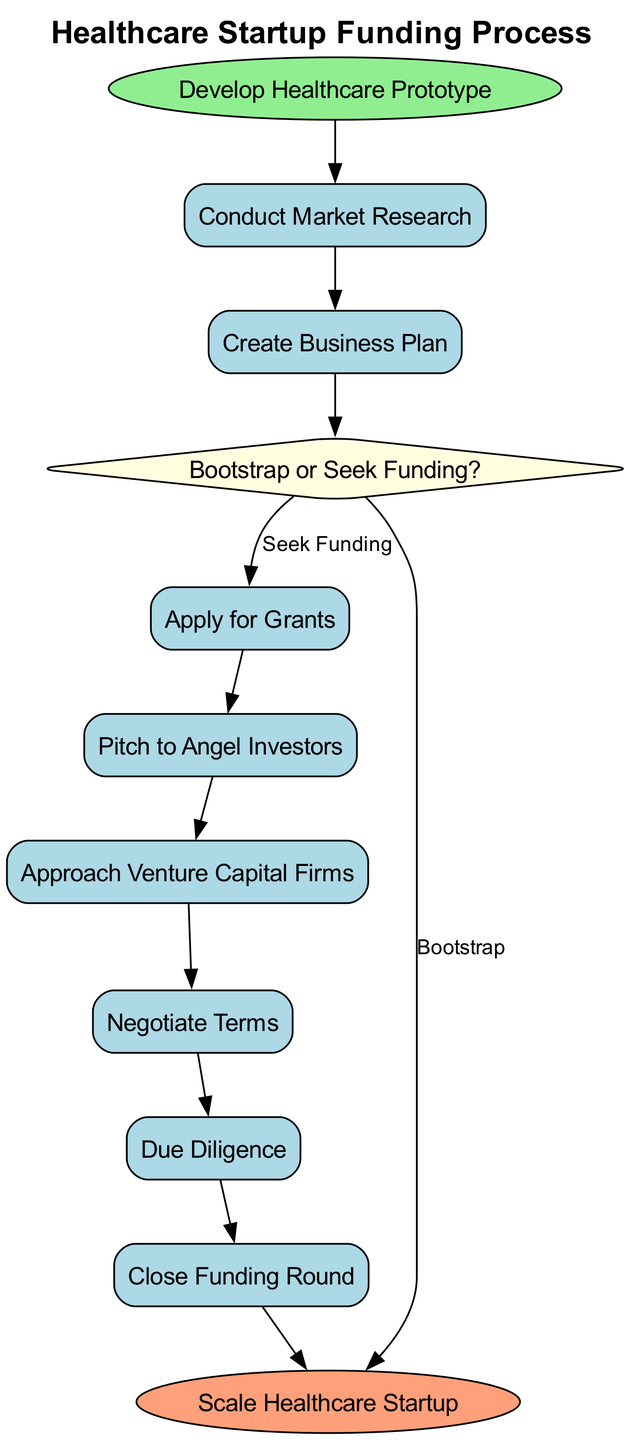What's the first step in the funding process? The first step is labeled as "Develop Healthcare Prototype," which initiates the entire funding process in the diagram.
Answer: Develop Healthcare Prototype How many decision points are in the diagram? There is only one decision point in the diagram, which is represented as "Bootstrap or Seek Funding?"
Answer: 1 What process comes after "Conduct Market Research"? The process that follows "Conduct Market Research" is "Create Business Plan." This is a direct sequential step shown in the flowchart.
Answer: Create Business Plan If the decision is to bootstrap, what is the next action? If the decision is to bootstrap, the next action is to "Scale Healthcare Startup," as indicated by the arrow leading directly from the decision point to the end step.
Answer: Scale Healthcare Startup What is the last step in the healthcare startup funding process? The last step is "Scale Healthcare Startup," which concludes the funding process laid out in the flowchart.
Answer: Scale Healthcare Startup What steps occur after "Pitch to Angel Investors"? After "Pitch to Angel Investors," the next step is "Approach Venture Capital Firms," followed by "Negotiate Terms," "Due Diligence," and "Close Funding Round." These steps are sequential and lead to the conclusion of the funding process.
Answer: Approach Venture Capital Firms How many processes are connected directly to the decision point? Three processes are connected directly to the decision point: "Apply for Grants," "Bootstrap," and "Seek Funding." Each has a distinct outcome based on the decision made.
Answer: 3 In which process does negotiation occur? Negotiation occurs during the "Negotiate Terms" process, which is a critical step following the approach to venture capital firms.
Answer: Negotiate Terms Which process immediately precedes "Close Funding Round"? The process that immediately precedes "Close Funding Round" is "Due Diligence," showing that due diligence is a prerequisite for closing the funding.
Answer: Due Diligence 